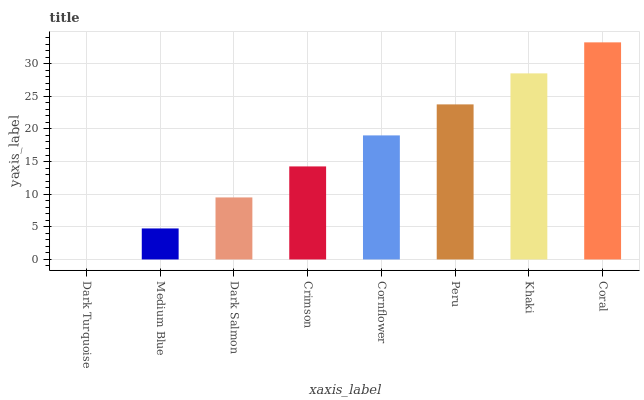Is Dark Turquoise the minimum?
Answer yes or no. Yes. Is Coral the maximum?
Answer yes or no. Yes. Is Medium Blue the minimum?
Answer yes or no. No. Is Medium Blue the maximum?
Answer yes or no. No. Is Medium Blue greater than Dark Turquoise?
Answer yes or no. Yes. Is Dark Turquoise less than Medium Blue?
Answer yes or no. Yes. Is Dark Turquoise greater than Medium Blue?
Answer yes or no. No. Is Medium Blue less than Dark Turquoise?
Answer yes or no. No. Is Cornflower the high median?
Answer yes or no. Yes. Is Crimson the low median?
Answer yes or no. Yes. Is Coral the high median?
Answer yes or no. No. Is Peru the low median?
Answer yes or no. No. 